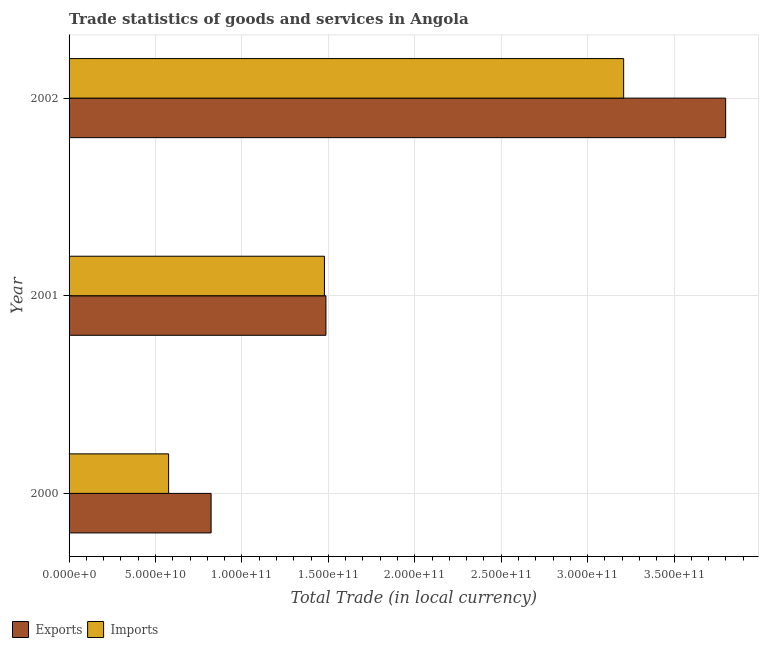How many different coloured bars are there?
Ensure brevity in your answer.  2. How many bars are there on the 2nd tick from the top?
Give a very brief answer. 2. How many bars are there on the 2nd tick from the bottom?
Your answer should be compact. 2. What is the label of the 2nd group of bars from the top?
Your answer should be compact. 2001. What is the export of goods and services in 2000?
Your answer should be very brief. 8.22e+1. Across all years, what is the maximum export of goods and services?
Ensure brevity in your answer.  3.80e+11. Across all years, what is the minimum export of goods and services?
Provide a succinct answer. 8.22e+1. In which year was the imports of goods and services maximum?
Offer a very short reply. 2002. What is the total export of goods and services in the graph?
Make the answer very short. 6.11e+11. What is the difference between the imports of goods and services in 2001 and that in 2002?
Ensure brevity in your answer.  -1.73e+11. What is the difference between the imports of goods and services in 2002 and the export of goods and services in 2000?
Make the answer very short. 2.39e+11. What is the average imports of goods and services per year?
Your answer should be very brief. 1.75e+11. In the year 2000, what is the difference between the export of goods and services and imports of goods and services?
Offer a terse response. 2.46e+1. In how many years, is the export of goods and services greater than 140000000000 LCU?
Keep it short and to the point. 2. What is the ratio of the imports of goods and services in 2000 to that in 2002?
Make the answer very short. 0.18. Is the export of goods and services in 2001 less than that in 2002?
Keep it short and to the point. Yes. Is the difference between the export of goods and services in 2001 and 2002 greater than the difference between the imports of goods and services in 2001 and 2002?
Ensure brevity in your answer.  No. What is the difference between the highest and the second highest imports of goods and services?
Your answer should be very brief. 1.73e+11. What is the difference between the highest and the lowest imports of goods and services?
Offer a very short reply. 2.63e+11. Is the sum of the export of goods and services in 2000 and 2001 greater than the maximum imports of goods and services across all years?
Your response must be concise. No. What does the 2nd bar from the top in 2000 represents?
Your response must be concise. Exports. What does the 2nd bar from the bottom in 2001 represents?
Your answer should be compact. Imports. How many bars are there?
Your response must be concise. 6. How many years are there in the graph?
Your answer should be very brief. 3. Are the values on the major ticks of X-axis written in scientific E-notation?
Offer a very short reply. Yes. Does the graph contain any zero values?
Offer a very short reply. No. Where does the legend appear in the graph?
Offer a very short reply. Bottom left. How are the legend labels stacked?
Your answer should be very brief. Horizontal. What is the title of the graph?
Make the answer very short. Trade statistics of goods and services in Angola. Does "Working only" appear as one of the legend labels in the graph?
Ensure brevity in your answer.  No. What is the label or title of the X-axis?
Make the answer very short. Total Trade (in local currency). What is the Total Trade (in local currency) of Exports in 2000?
Your answer should be compact. 8.22e+1. What is the Total Trade (in local currency) of Imports in 2000?
Ensure brevity in your answer.  5.76e+1. What is the Total Trade (in local currency) in Exports in 2001?
Give a very brief answer. 1.49e+11. What is the Total Trade (in local currency) in Imports in 2001?
Provide a short and direct response. 1.48e+11. What is the Total Trade (in local currency) in Exports in 2002?
Your answer should be very brief. 3.80e+11. What is the Total Trade (in local currency) in Imports in 2002?
Make the answer very short. 3.21e+11. Across all years, what is the maximum Total Trade (in local currency) of Exports?
Your response must be concise. 3.80e+11. Across all years, what is the maximum Total Trade (in local currency) in Imports?
Give a very brief answer. 3.21e+11. Across all years, what is the minimum Total Trade (in local currency) in Exports?
Your response must be concise. 8.22e+1. Across all years, what is the minimum Total Trade (in local currency) of Imports?
Offer a terse response. 5.76e+1. What is the total Total Trade (in local currency) of Exports in the graph?
Ensure brevity in your answer.  6.11e+11. What is the total Total Trade (in local currency) in Imports in the graph?
Give a very brief answer. 5.26e+11. What is the difference between the Total Trade (in local currency) of Exports in 2000 and that in 2001?
Your answer should be very brief. -6.64e+1. What is the difference between the Total Trade (in local currency) in Imports in 2000 and that in 2001?
Offer a terse response. -9.01e+1. What is the difference between the Total Trade (in local currency) in Exports in 2000 and that in 2002?
Provide a short and direct response. -2.98e+11. What is the difference between the Total Trade (in local currency) in Imports in 2000 and that in 2002?
Provide a succinct answer. -2.63e+11. What is the difference between the Total Trade (in local currency) in Exports in 2001 and that in 2002?
Your answer should be very brief. -2.31e+11. What is the difference between the Total Trade (in local currency) of Imports in 2001 and that in 2002?
Provide a succinct answer. -1.73e+11. What is the difference between the Total Trade (in local currency) of Exports in 2000 and the Total Trade (in local currency) of Imports in 2001?
Ensure brevity in your answer.  -6.56e+1. What is the difference between the Total Trade (in local currency) in Exports in 2000 and the Total Trade (in local currency) in Imports in 2002?
Offer a terse response. -2.39e+11. What is the difference between the Total Trade (in local currency) in Exports in 2001 and the Total Trade (in local currency) in Imports in 2002?
Provide a short and direct response. -1.72e+11. What is the average Total Trade (in local currency) of Exports per year?
Provide a short and direct response. 2.04e+11. What is the average Total Trade (in local currency) of Imports per year?
Ensure brevity in your answer.  1.75e+11. In the year 2000, what is the difference between the Total Trade (in local currency) in Exports and Total Trade (in local currency) in Imports?
Keep it short and to the point. 2.46e+1. In the year 2001, what is the difference between the Total Trade (in local currency) in Exports and Total Trade (in local currency) in Imports?
Offer a terse response. 8.72e+08. In the year 2002, what is the difference between the Total Trade (in local currency) in Exports and Total Trade (in local currency) in Imports?
Provide a short and direct response. 5.90e+1. What is the ratio of the Total Trade (in local currency) of Exports in 2000 to that in 2001?
Provide a short and direct response. 0.55. What is the ratio of the Total Trade (in local currency) of Imports in 2000 to that in 2001?
Keep it short and to the point. 0.39. What is the ratio of the Total Trade (in local currency) of Exports in 2000 to that in 2002?
Offer a terse response. 0.22. What is the ratio of the Total Trade (in local currency) of Imports in 2000 to that in 2002?
Offer a terse response. 0.18. What is the ratio of the Total Trade (in local currency) in Exports in 2001 to that in 2002?
Offer a very short reply. 0.39. What is the ratio of the Total Trade (in local currency) of Imports in 2001 to that in 2002?
Your response must be concise. 0.46. What is the difference between the highest and the second highest Total Trade (in local currency) of Exports?
Ensure brevity in your answer.  2.31e+11. What is the difference between the highest and the second highest Total Trade (in local currency) in Imports?
Offer a terse response. 1.73e+11. What is the difference between the highest and the lowest Total Trade (in local currency) in Exports?
Ensure brevity in your answer.  2.98e+11. What is the difference between the highest and the lowest Total Trade (in local currency) in Imports?
Give a very brief answer. 2.63e+11. 